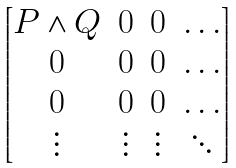Convert formula to latex. <formula><loc_0><loc_0><loc_500><loc_500>\begin{bmatrix} P \wedge Q & 0 & 0 & \dots \\ 0 & 0 & 0 & \dots \\ 0 & 0 & 0 & \dots \\ \vdots & \vdots & \vdots & \ddots \end{bmatrix}</formula> 